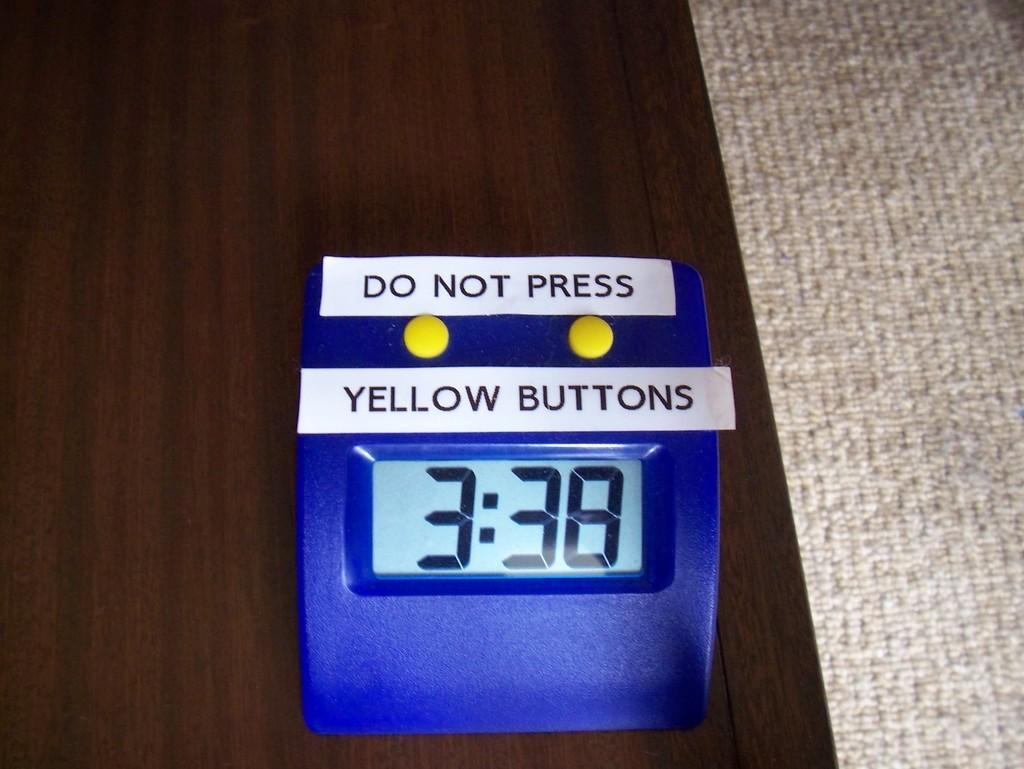<image>
Relay a brief, clear account of the picture shown. A clock with added labels of Do Not Press Yellow Button is on a brown table. 